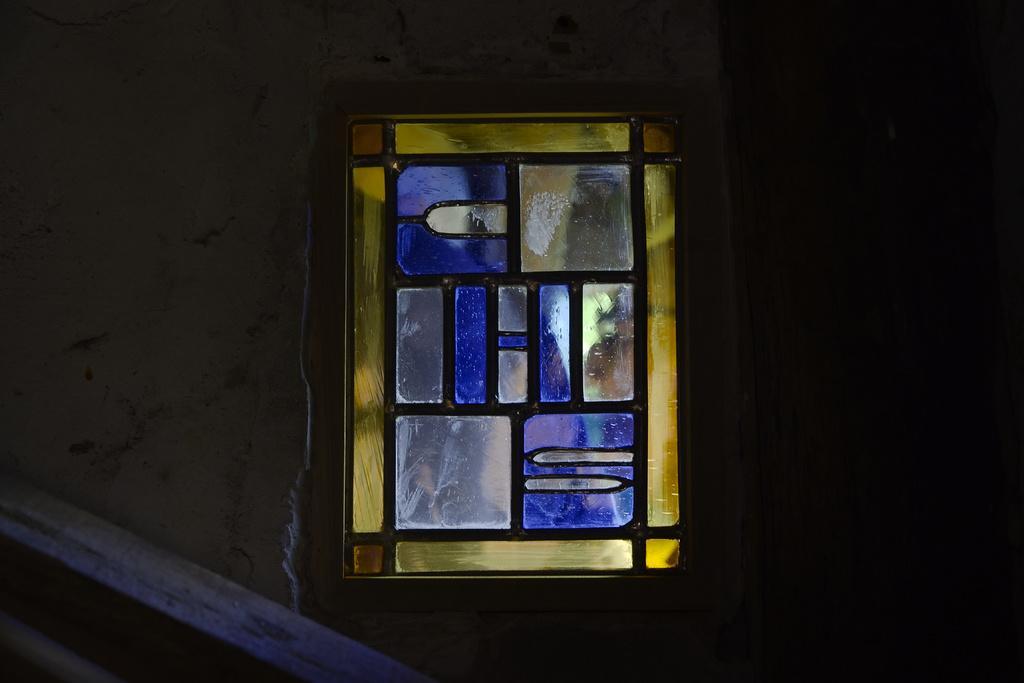Describe this image in one or two sentences. In this image we can see a window with glass. On the left side, we can see a wall. On the right side the image is dark. 